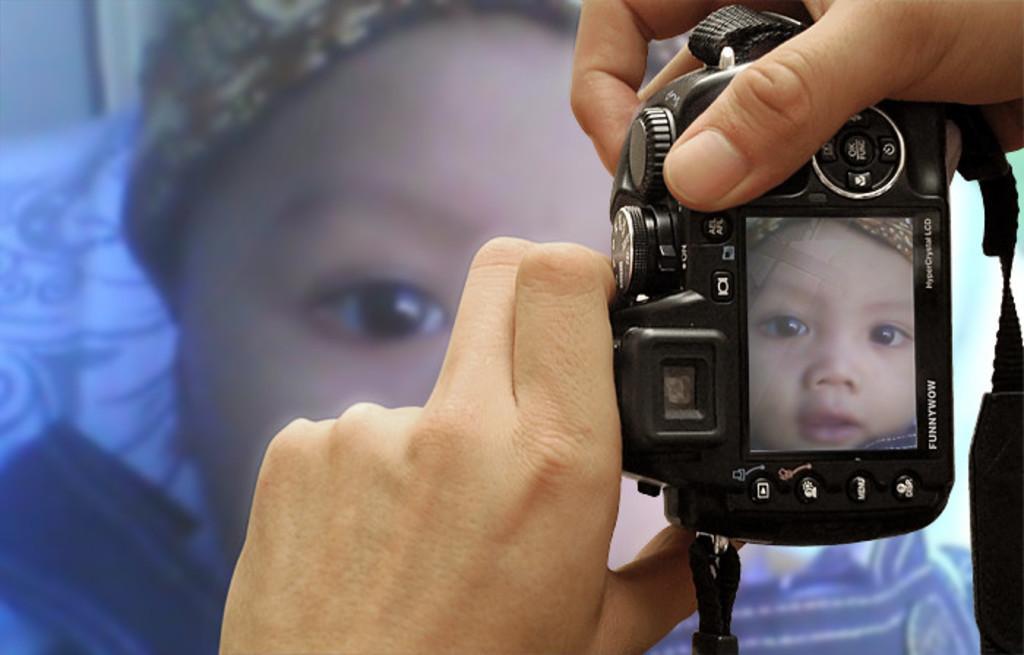In one or two sentences, can you explain what this image depicts? In this image I can see a person is trying to capture the image of a baby in the camera by holding it with the hands. 